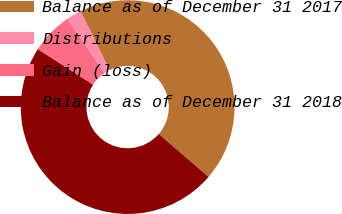Convert chart. <chart><loc_0><loc_0><loc_500><loc_500><pie_chart><fcel>Balance as of December 31 2017<fcel>Distributions<fcel>Gain (loss)<fcel>Balance as of December 31 2018<nl><fcel>43.62%<fcel>2.24%<fcel>6.38%<fcel>47.76%<nl></chart> 